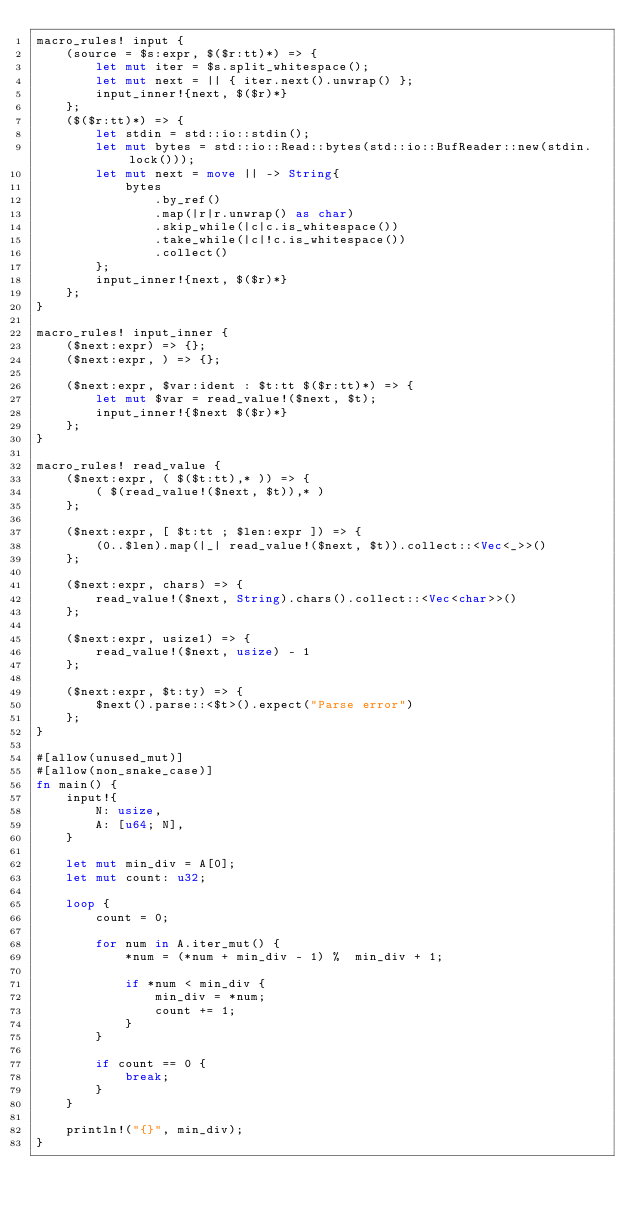Convert code to text. <code><loc_0><loc_0><loc_500><loc_500><_Rust_>macro_rules! input {
    (source = $s:expr, $($r:tt)*) => {
        let mut iter = $s.split_whitespace();
        let mut next = || { iter.next().unwrap() };
        input_inner!{next, $($r)*}
    };
    ($($r:tt)*) => {
        let stdin = std::io::stdin();
        let mut bytes = std::io::Read::bytes(std::io::BufReader::new(stdin.lock()));
        let mut next = move || -> String{
            bytes
                .by_ref()
                .map(|r|r.unwrap() as char)
                .skip_while(|c|c.is_whitespace())
                .take_while(|c|!c.is_whitespace())
                .collect()
        };
        input_inner!{next, $($r)*}
    };
}

macro_rules! input_inner {
    ($next:expr) => {};
    ($next:expr, ) => {};

    ($next:expr, $var:ident : $t:tt $($r:tt)*) => {
        let mut $var = read_value!($next, $t);
        input_inner!{$next $($r)*}
    };
}

macro_rules! read_value {
    ($next:expr, ( $($t:tt),* )) => {
        ( $(read_value!($next, $t)),* )
    };

    ($next:expr, [ $t:tt ; $len:expr ]) => {
        (0..$len).map(|_| read_value!($next, $t)).collect::<Vec<_>>()
    };

    ($next:expr, chars) => {
        read_value!($next, String).chars().collect::<Vec<char>>()
    };

    ($next:expr, usize1) => {
        read_value!($next, usize) - 1
    };

    ($next:expr, $t:ty) => {
        $next().parse::<$t>().expect("Parse error")
    };
}

#[allow(unused_mut)]
#[allow(non_snake_case)]
fn main() {
    input!{
        N: usize,
        A: [u64; N],
    }
    
    let mut min_div = A[0];
    let mut count: u32;

    loop {
        count = 0;

        for num in A.iter_mut() {
            *num = (*num + min_div - 1) %  min_div + 1;

            if *num < min_div {
                min_div = *num;
                count += 1;
            }
        }

        if count == 0 {
            break;
        }
    }

    println!("{}", min_div);
}
</code> 